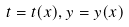Convert formula to latex. <formula><loc_0><loc_0><loc_500><loc_500>t = t ( x ) , y = y ( x )</formula> 